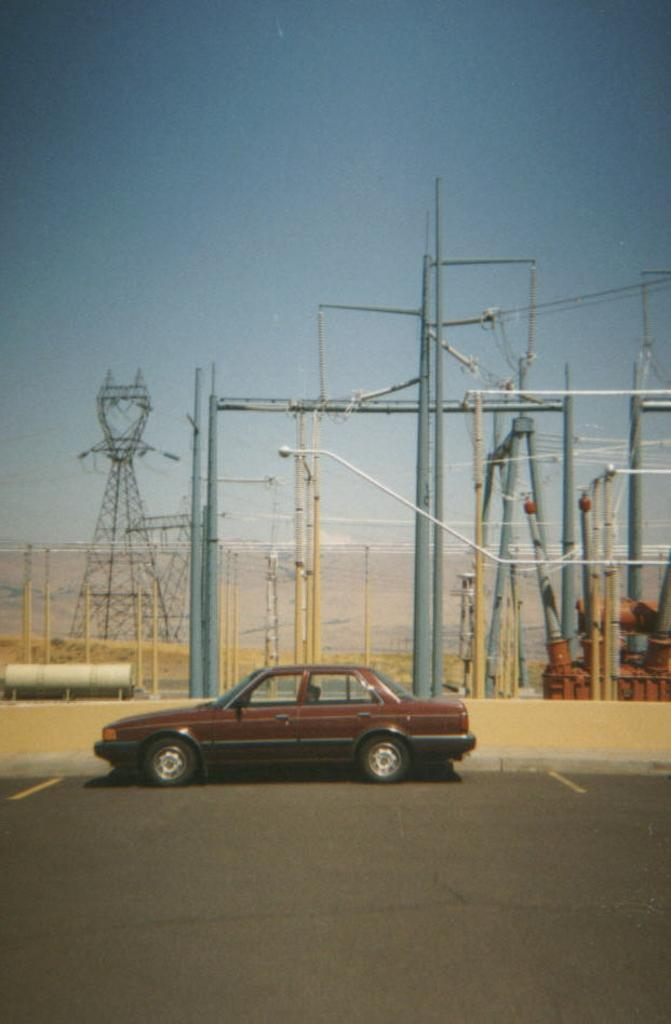What is the main subject of the image? The main subject of the image is a car on the road. What other object can be seen in the middle of the image? There is a power substation in the middle of the image. What is visible at the top of the image? The sky is visible at the top of the image. What type of liquid can be seen flowing from the car's exhaust in the image? There is no liquid flowing from the car's exhaust in the image. What attraction is located near the power substation in the image? There is no attraction mentioned or visible in the image; it only features a car on the road and a power substation. 